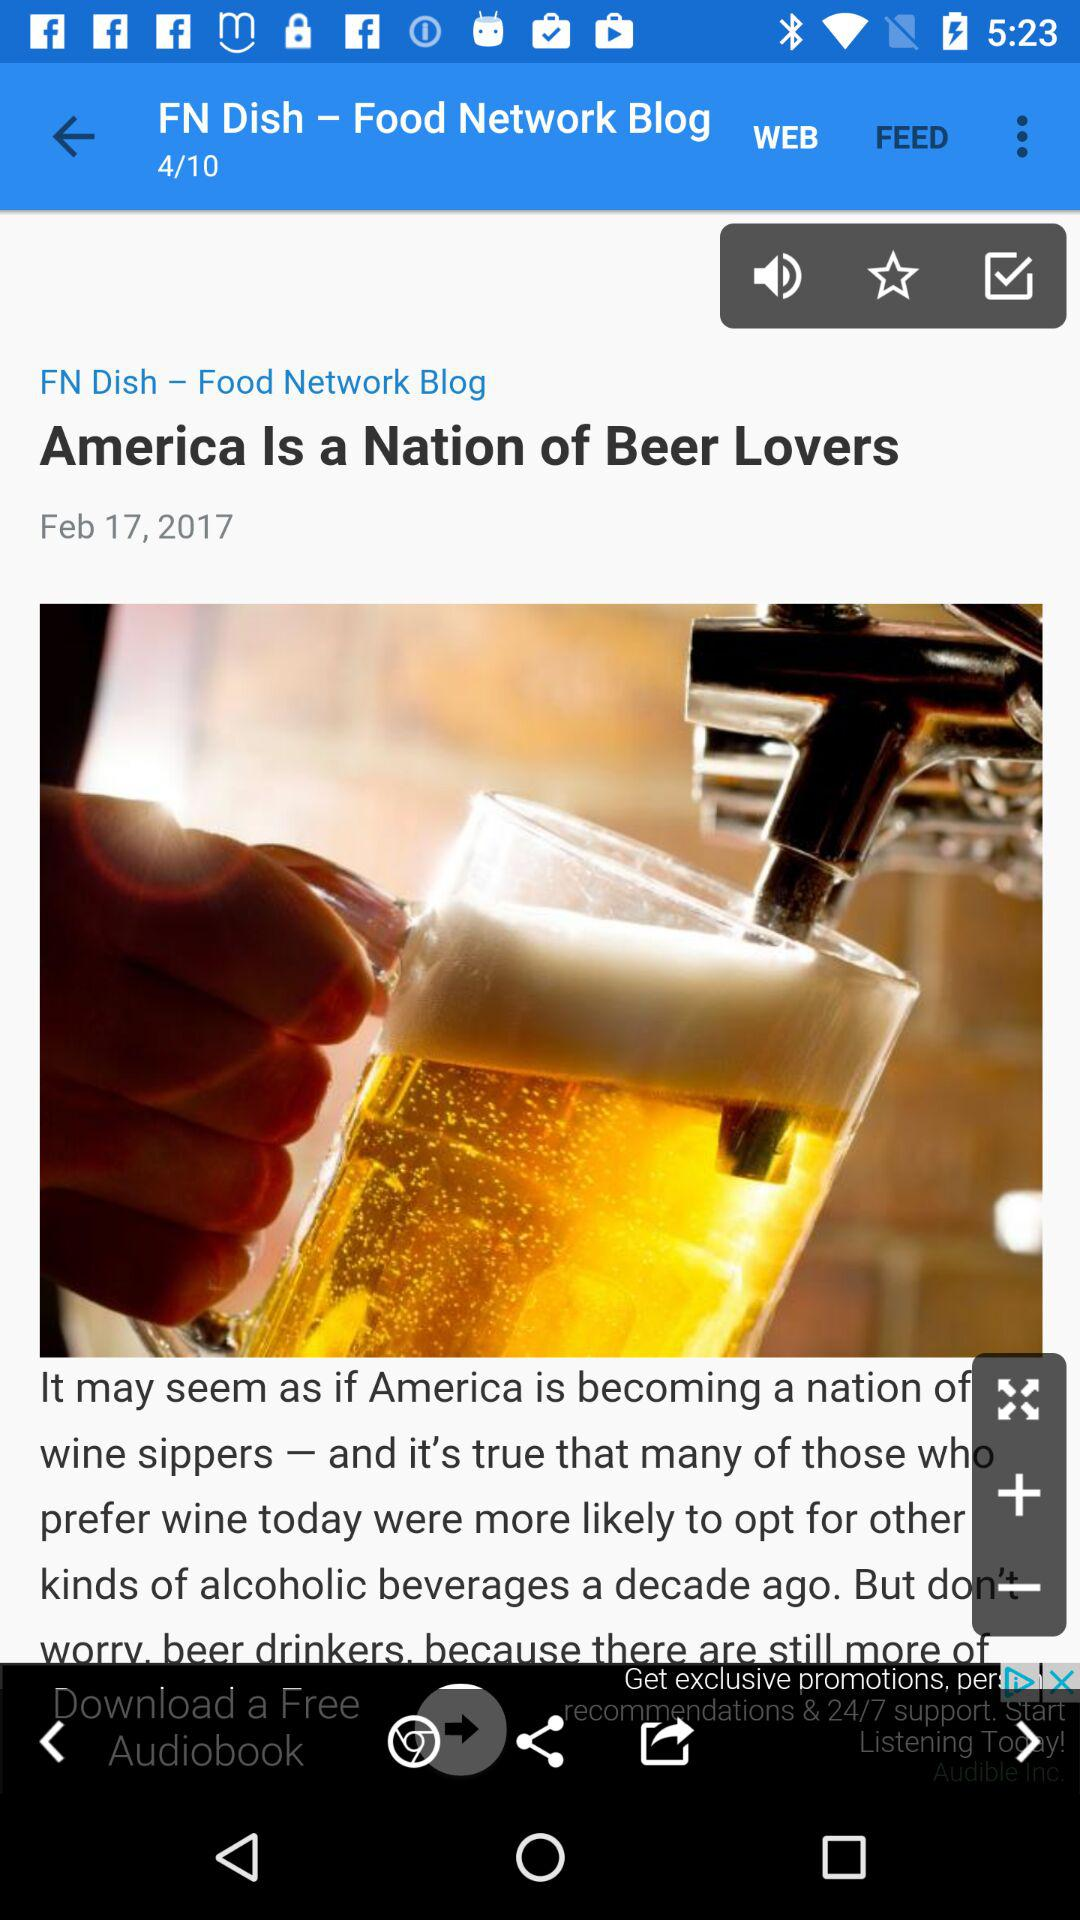Which "Food Network Blog" page am I at? You are at the 4th "Food Network Blog" page. 